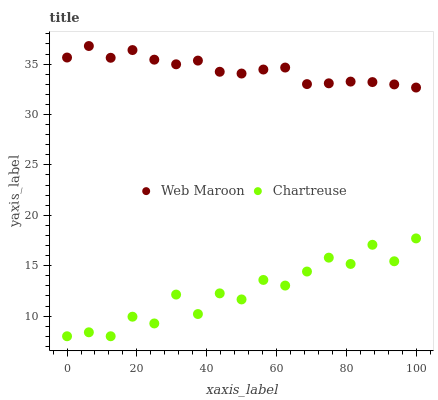Does Chartreuse have the minimum area under the curve?
Answer yes or no. Yes. Does Web Maroon have the maximum area under the curve?
Answer yes or no. Yes. Does Web Maroon have the minimum area under the curve?
Answer yes or no. No. Is Web Maroon the smoothest?
Answer yes or no. Yes. Is Chartreuse the roughest?
Answer yes or no. Yes. Is Web Maroon the roughest?
Answer yes or no. No. Does Chartreuse have the lowest value?
Answer yes or no. Yes. Does Web Maroon have the lowest value?
Answer yes or no. No. Does Web Maroon have the highest value?
Answer yes or no. Yes. Is Chartreuse less than Web Maroon?
Answer yes or no. Yes. Is Web Maroon greater than Chartreuse?
Answer yes or no. Yes. Does Chartreuse intersect Web Maroon?
Answer yes or no. No. 